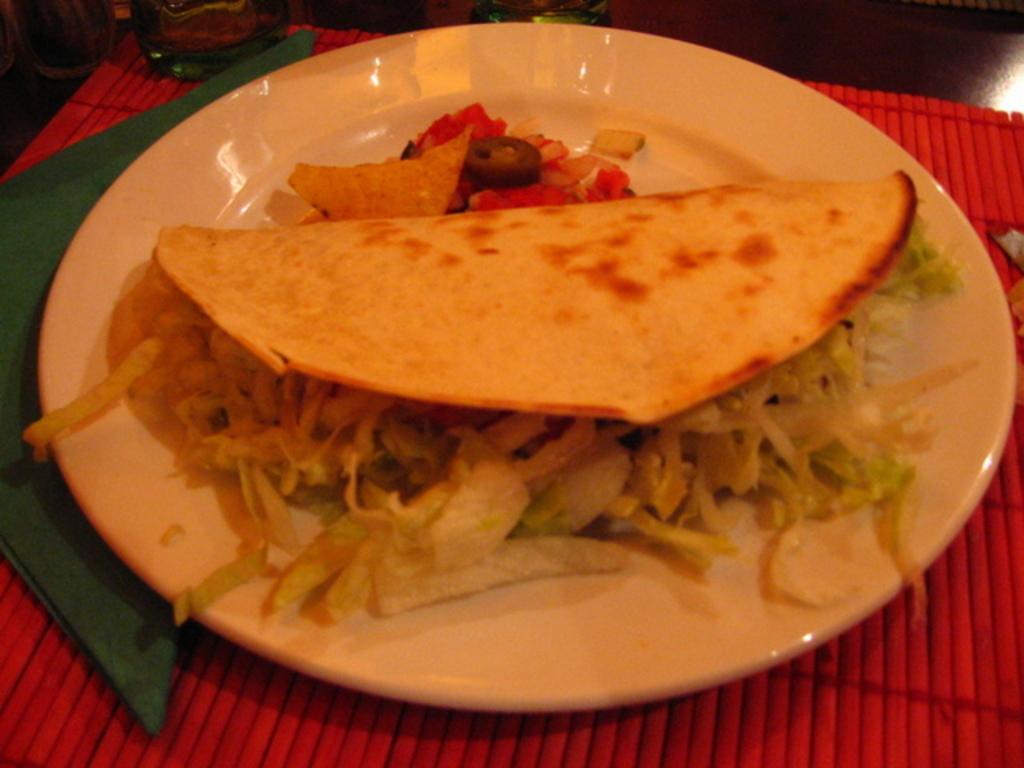Describe this image in one or two sentences. In this image we can see food in a plate, cloth, and other objects on a table. 